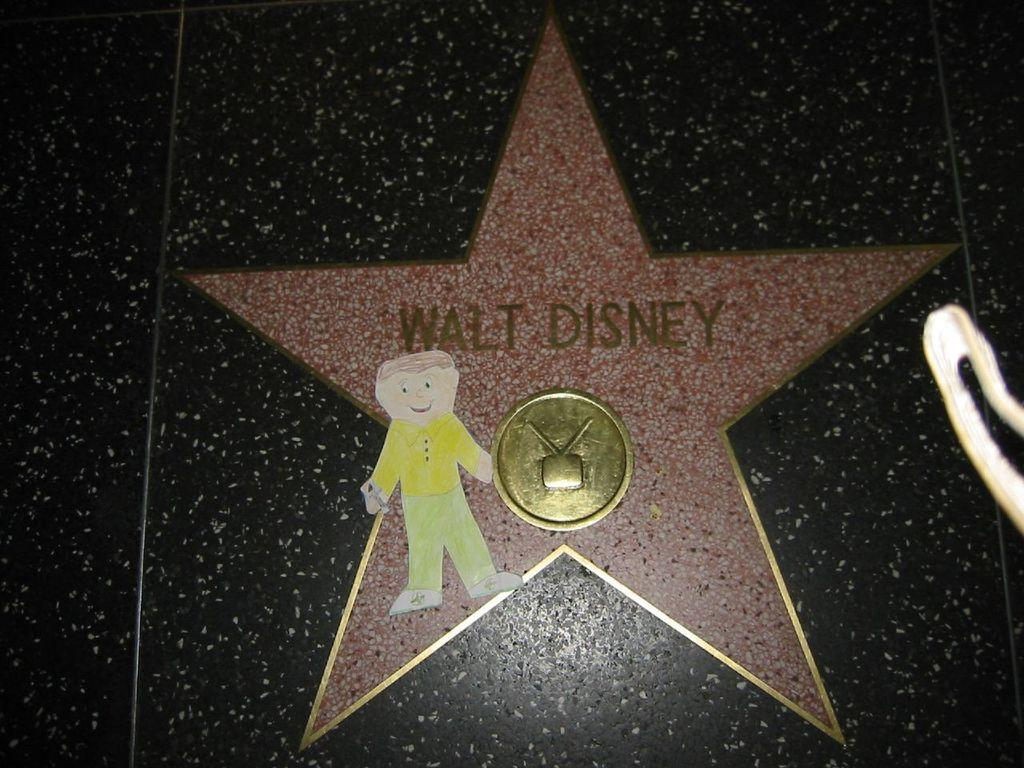What is the color of the surface in the image? The surface in the image is black. What is written on the star in the image? There is a star with something written on it in the image. What is the color of the golden thing in the image? There is a golden color thing in the image. What can be seen in the drawing in the image? There is a drawing of a child in the image. How many toes are visible on the child's foot in the image? There is no child's foot visible in the image, only a drawing of a child. What type of pencil is being used to draw the child in the image? There is no pencil visible in the image, only a drawing of a child. 